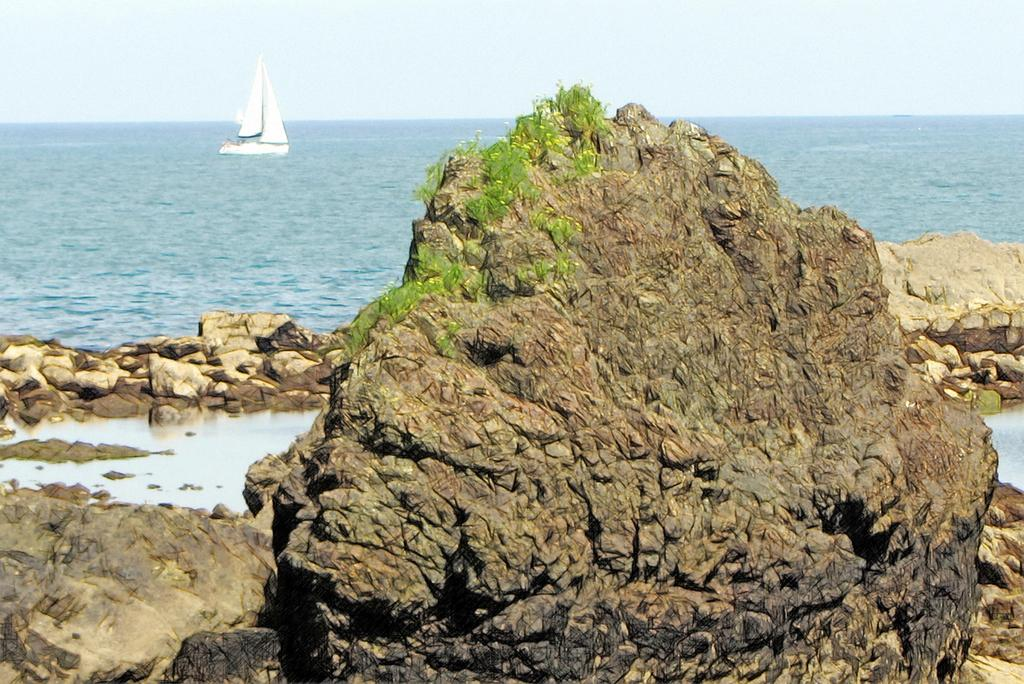What type of objects can be seen in the image? There are stones and a white-colored boat in the image. What natural elements are present in the image? There is water and the sky visible in the image. What is the color of the boat in the image? The boat is white-colored. What can be found on a rock in the front of the image? There are green-colored things on a rock in the front of the image. Can you hear the ladybug crawling on the boat in the image? There is no ladybug present in the image, so it is not possible to hear it crawling on the boat. 